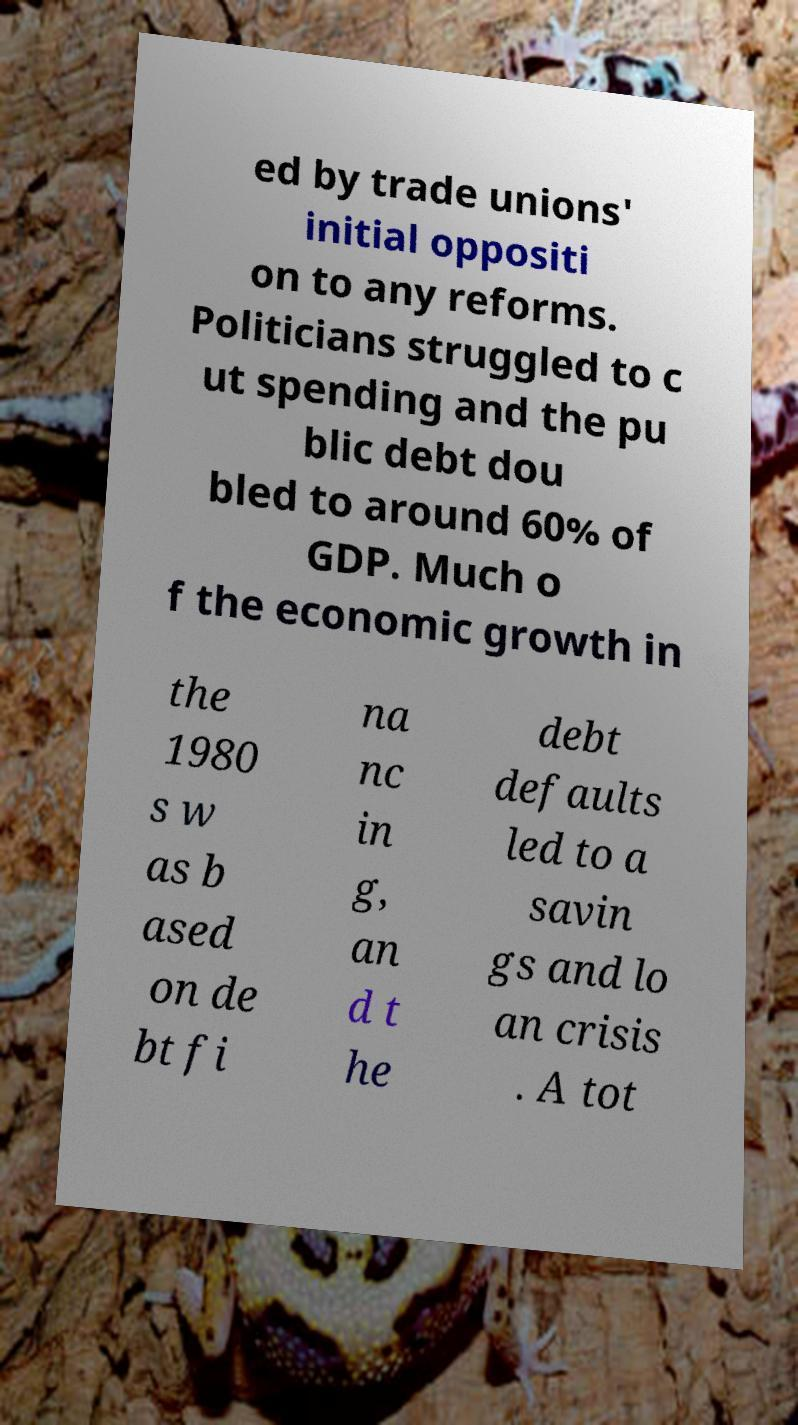Please read and relay the text visible in this image. What does it say? ed by trade unions' initial oppositi on to any reforms. Politicians struggled to c ut spending and the pu blic debt dou bled to around 60% of GDP. Much o f the economic growth in the 1980 s w as b ased on de bt fi na nc in g, an d t he debt defaults led to a savin gs and lo an crisis . A tot 